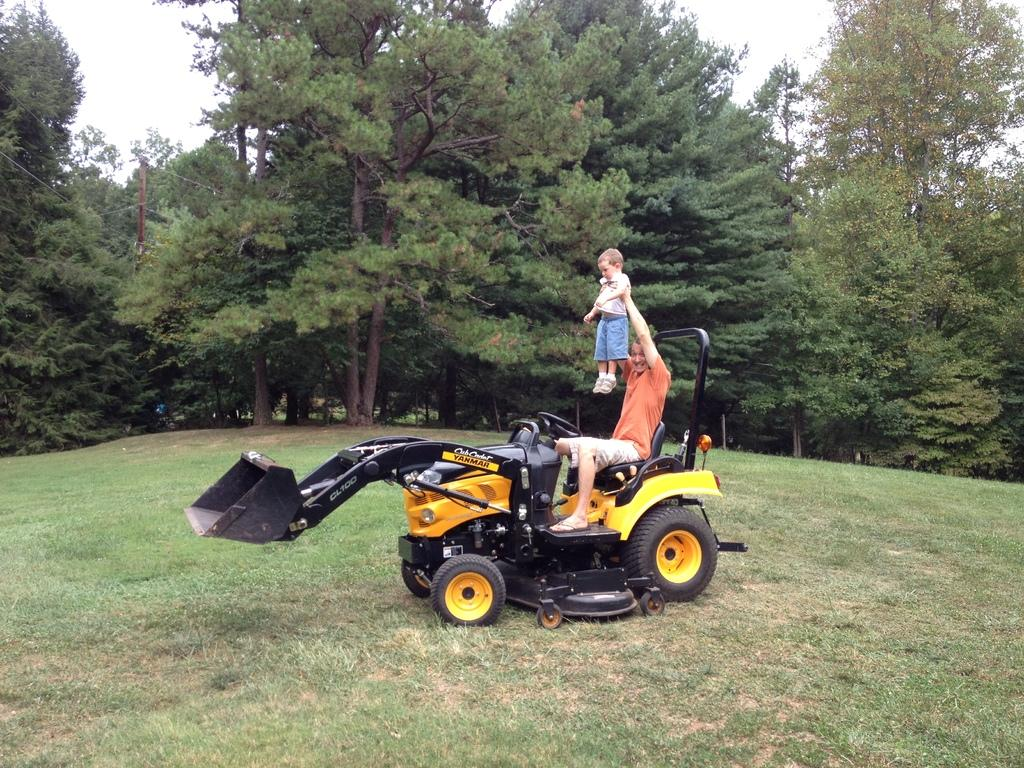What is the main subject of the image? There is a man in the image. What is the man doing in the image? The man is seated on a vehicle and holding a baby. What can be seen in the background of the image? There are trees and grass visible in the background of the image. What color is the man's shirt in the image? The provided facts do not mention the color of the man's shirt, so we cannot determine the color from the image. How old is the man's daughter in the image? The provided facts do not mention the man having a daughter, so we cannot determine the age of a daughter from the image. 